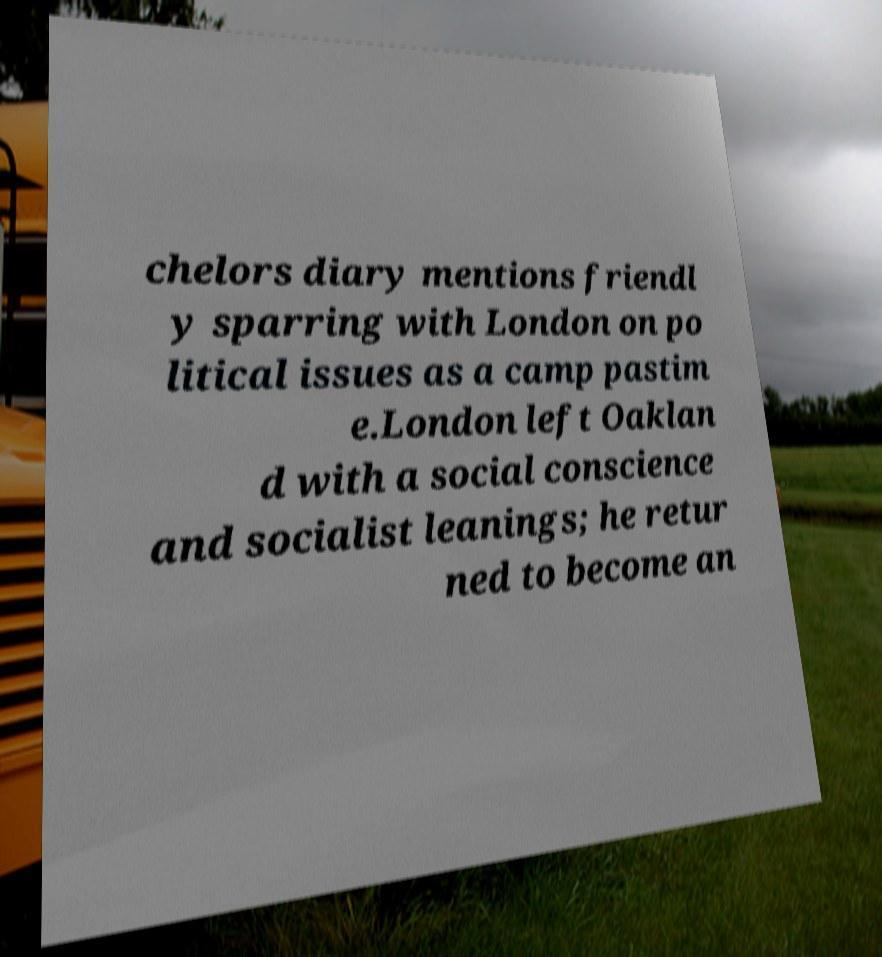Can you accurately transcribe the text from the provided image for me? chelors diary mentions friendl y sparring with London on po litical issues as a camp pastim e.London left Oaklan d with a social conscience and socialist leanings; he retur ned to become an 